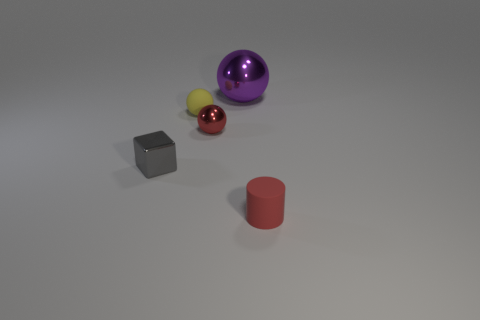Subtract all tiny spheres. How many spheres are left? 1 Subtract all yellow balls. How many balls are left? 2 Add 4 red metallic objects. How many objects exist? 9 Subtract all spheres. How many objects are left? 2 Subtract 1 cylinders. How many cylinders are left? 0 Subtract all large blue blocks. Subtract all metallic balls. How many objects are left? 3 Add 5 gray objects. How many gray objects are left? 6 Add 2 red spheres. How many red spheres exist? 3 Subtract 0 blue cylinders. How many objects are left? 5 Subtract all green balls. Subtract all cyan cubes. How many balls are left? 3 